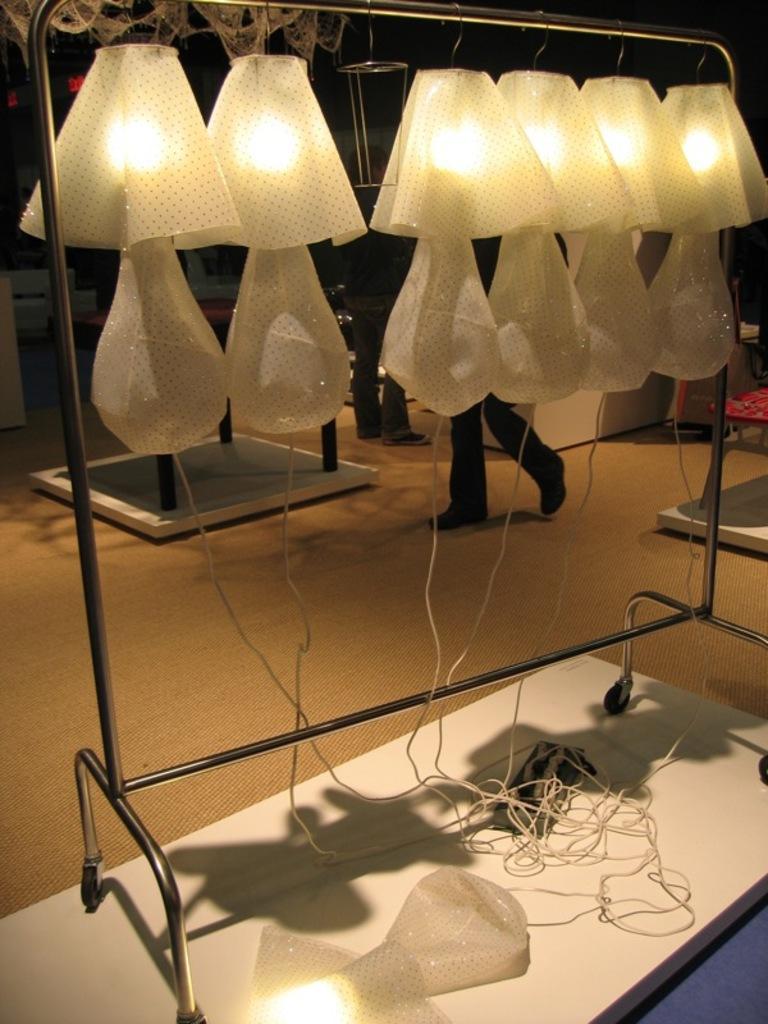Describe this image in one or two sentences. In this picture we can see a switchboard, wires and an object on a white surface. There are a few lights on the stand. We can see two people and other objects in the background. 